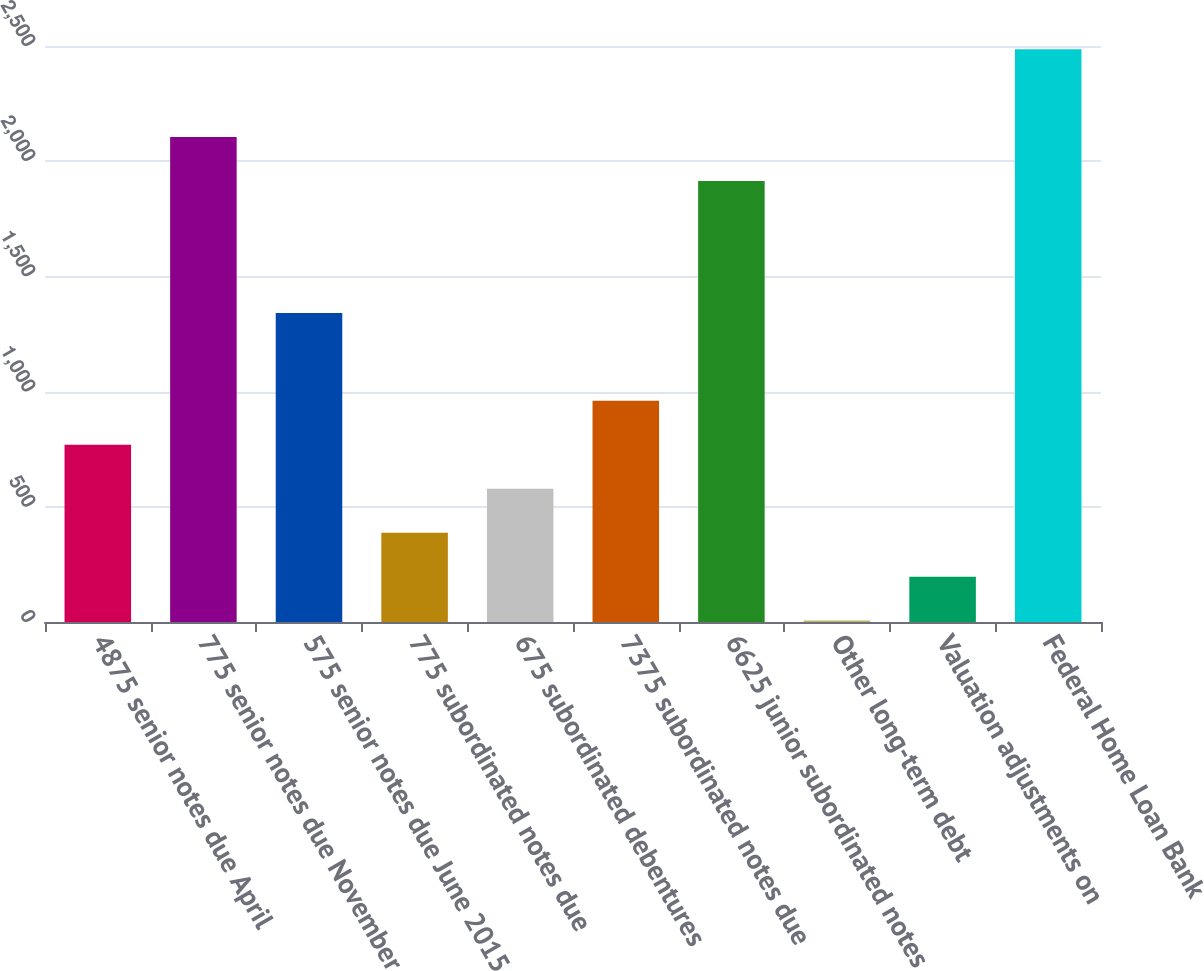Convert chart to OTSL. <chart><loc_0><loc_0><loc_500><loc_500><bar_chart><fcel>4875 senior notes due April<fcel>775 senior notes due November<fcel>575 senior notes due June 2015<fcel>775 subordinated notes due<fcel>675 subordinated debentures<fcel>7375 subordinated notes due<fcel>6625 junior subordinated notes<fcel>Other long-term debt<fcel>Valuation adjustments on<fcel>Federal Home Loan Bank<nl><fcel>769.2<fcel>2104.8<fcel>1341.6<fcel>387.6<fcel>578.4<fcel>960<fcel>1914<fcel>6<fcel>196.8<fcel>2486.4<nl></chart> 